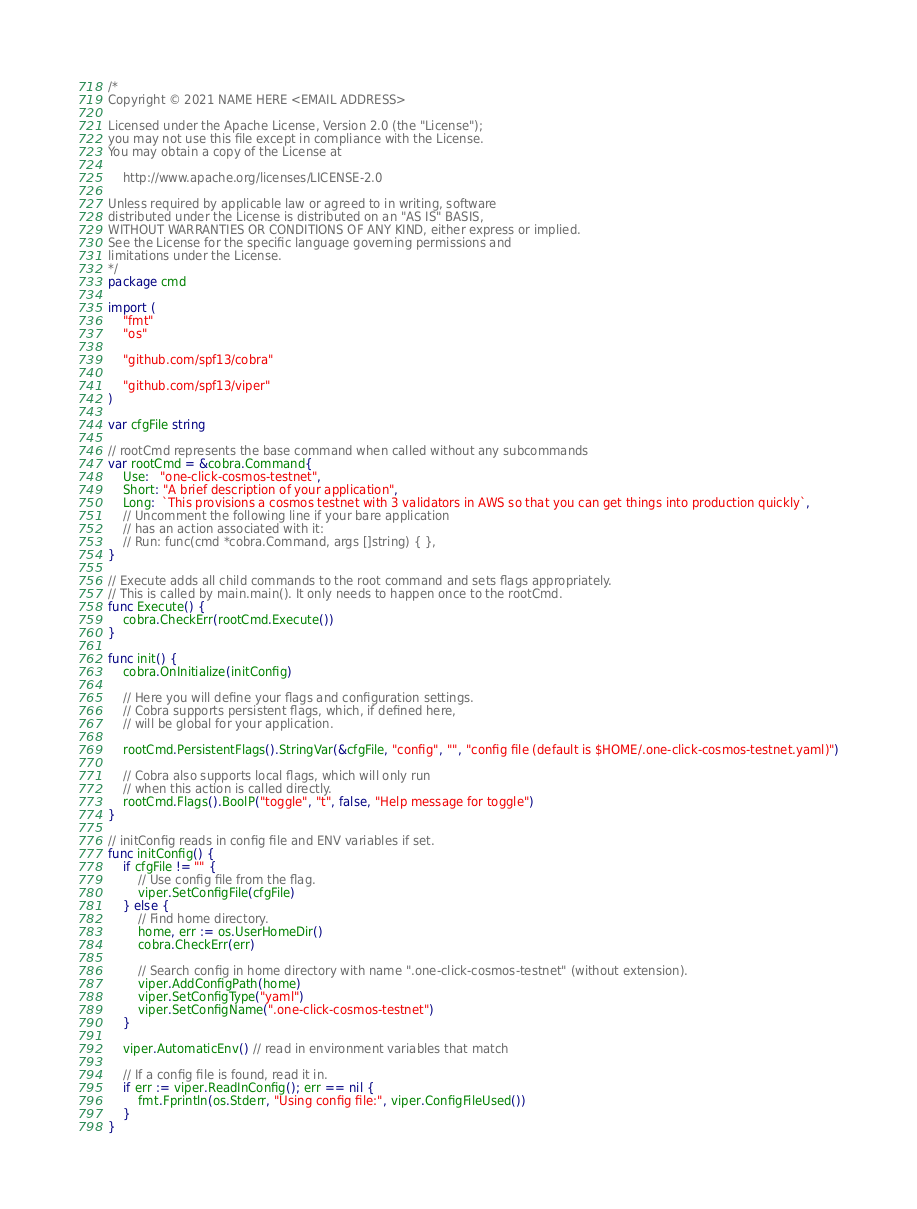<code> <loc_0><loc_0><loc_500><loc_500><_Go_>/*
Copyright © 2021 NAME HERE <EMAIL ADDRESS>

Licensed under the Apache License, Version 2.0 (the "License");
you may not use this file except in compliance with the License.
You may obtain a copy of the License at

    http://www.apache.org/licenses/LICENSE-2.0

Unless required by applicable law or agreed to in writing, software
distributed under the License is distributed on an "AS IS" BASIS,
WITHOUT WARRANTIES OR CONDITIONS OF ANY KIND, either express or implied.
See the License for the specific language governing permissions and
limitations under the License.
*/
package cmd

import (
	"fmt"
	"os"

	"github.com/spf13/cobra"

	"github.com/spf13/viper"
)

var cfgFile string

// rootCmd represents the base command when called without any subcommands
var rootCmd = &cobra.Command{
	Use:   "one-click-cosmos-testnet",
	Short: "A brief description of your application",
	Long:  `This provisions a cosmos testnet with 3 validators in AWS so that you can get things into production quickly`,
	// Uncomment the following line if your bare application
	// has an action associated with it:
	// Run: func(cmd *cobra.Command, args []string) { },
}

// Execute adds all child commands to the root command and sets flags appropriately.
// This is called by main.main(). It only needs to happen once to the rootCmd.
func Execute() {
	cobra.CheckErr(rootCmd.Execute())
}

func init() {
	cobra.OnInitialize(initConfig)

	// Here you will define your flags and configuration settings.
	// Cobra supports persistent flags, which, if defined here,
	// will be global for your application.

	rootCmd.PersistentFlags().StringVar(&cfgFile, "config", "", "config file (default is $HOME/.one-click-cosmos-testnet.yaml)")

	// Cobra also supports local flags, which will only run
	// when this action is called directly.
	rootCmd.Flags().BoolP("toggle", "t", false, "Help message for toggle")
}

// initConfig reads in config file and ENV variables if set.
func initConfig() {
	if cfgFile != "" {
		// Use config file from the flag.
		viper.SetConfigFile(cfgFile)
	} else {
		// Find home directory.
		home, err := os.UserHomeDir()
		cobra.CheckErr(err)

		// Search config in home directory with name ".one-click-cosmos-testnet" (without extension).
		viper.AddConfigPath(home)
		viper.SetConfigType("yaml")
		viper.SetConfigName(".one-click-cosmos-testnet")
	}

	viper.AutomaticEnv() // read in environment variables that match

	// If a config file is found, read it in.
	if err := viper.ReadInConfig(); err == nil {
		fmt.Fprintln(os.Stderr, "Using config file:", viper.ConfigFileUsed())
	}
}
</code> 